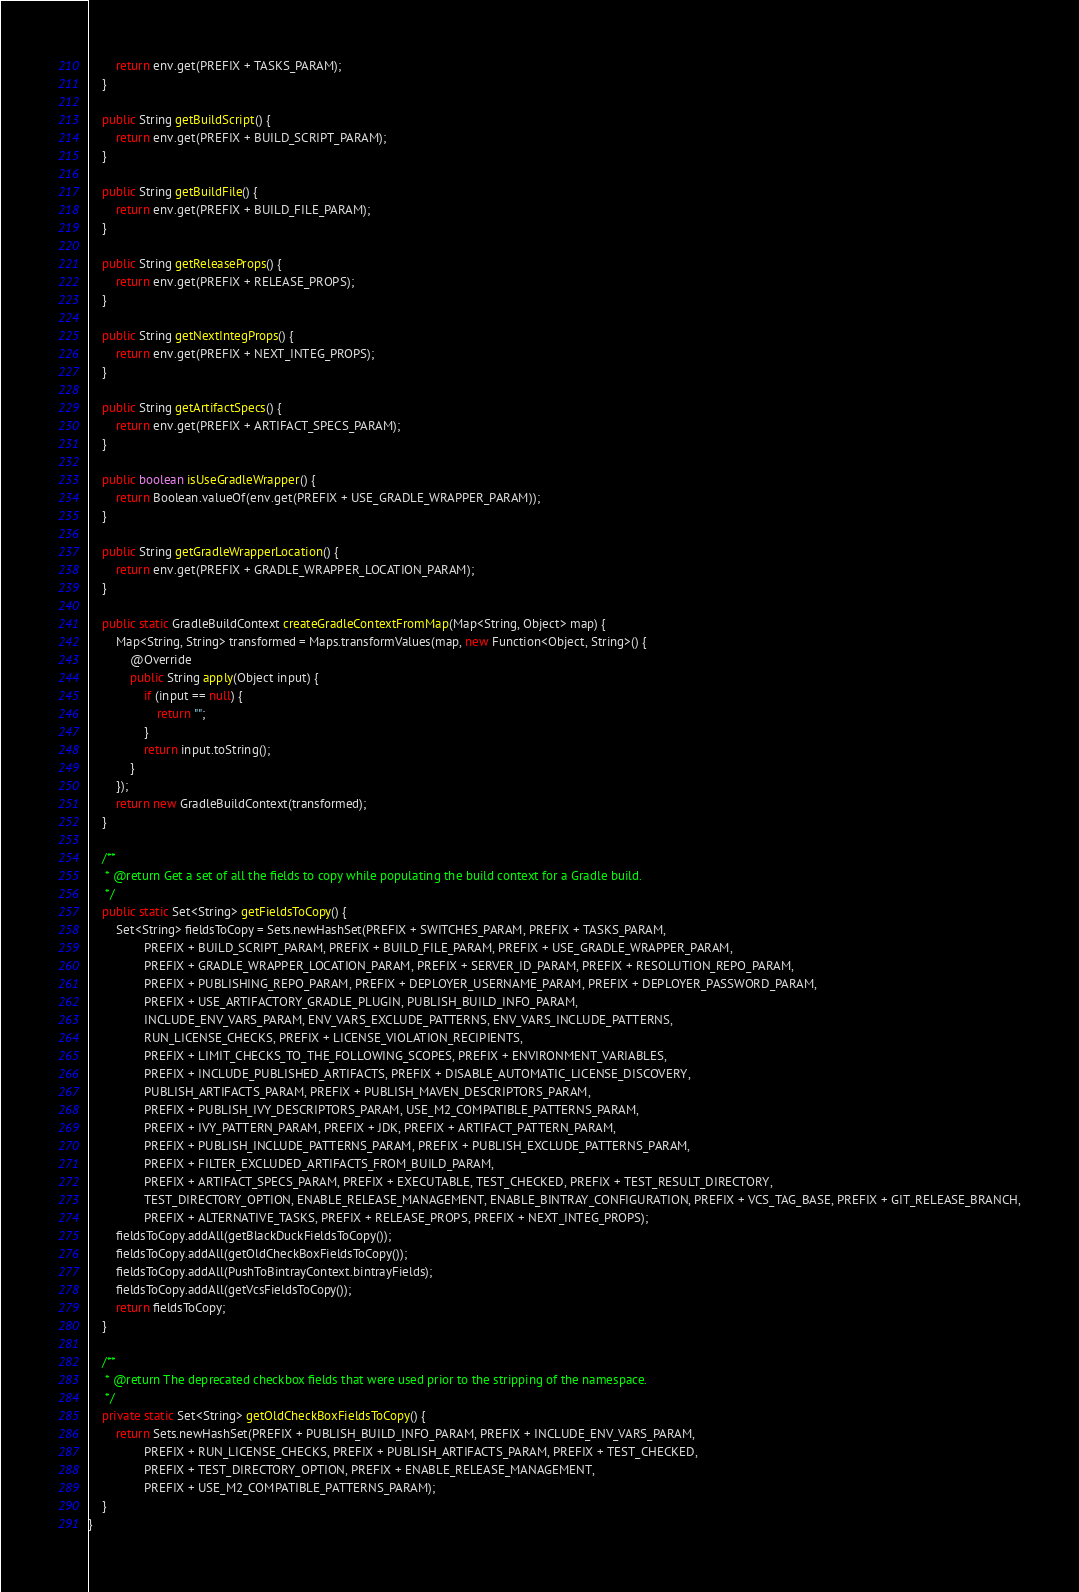Convert code to text. <code><loc_0><loc_0><loc_500><loc_500><_Java_>        return env.get(PREFIX + TASKS_PARAM);
    }

    public String getBuildScript() {
        return env.get(PREFIX + BUILD_SCRIPT_PARAM);
    }

    public String getBuildFile() {
        return env.get(PREFIX + BUILD_FILE_PARAM);
    }

    public String getReleaseProps() {
        return env.get(PREFIX + RELEASE_PROPS);
    }

    public String getNextIntegProps() {
        return env.get(PREFIX + NEXT_INTEG_PROPS);
    }

    public String getArtifactSpecs() {
        return env.get(PREFIX + ARTIFACT_SPECS_PARAM);
    }

    public boolean isUseGradleWrapper() {
        return Boolean.valueOf(env.get(PREFIX + USE_GRADLE_WRAPPER_PARAM));
    }

    public String getGradleWrapperLocation() {
        return env.get(PREFIX + GRADLE_WRAPPER_LOCATION_PARAM);
    }

    public static GradleBuildContext createGradleContextFromMap(Map<String, Object> map) {
        Map<String, String> transformed = Maps.transformValues(map, new Function<Object, String>() {
            @Override
            public String apply(Object input) {
                if (input == null) {
                    return "";
                }
                return input.toString();
            }
        });
        return new GradleBuildContext(transformed);
    }

    /**
     * @return Get a set of all the fields to copy while populating the build context for a Gradle build.
     */
    public static Set<String> getFieldsToCopy() {
        Set<String> fieldsToCopy = Sets.newHashSet(PREFIX + SWITCHES_PARAM, PREFIX + TASKS_PARAM,
                PREFIX + BUILD_SCRIPT_PARAM, PREFIX + BUILD_FILE_PARAM, PREFIX + USE_GRADLE_WRAPPER_PARAM,
                PREFIX + GRADLE_WRAPPER_LOCATION_PARAM, PREFIX + SERVER_ID_PARAM, PREFIX + RESOLUTION_REPO_PARAM,
                PREFIX + PUBLISHING_REPO_PARAM, PREFIX + DEPLOYER_USERNAME_PARAM, PREFIX + DEPLOYER_PASSWORD_PARAM,
                PREFIX + USE_ARTIFACTORY_GRADLE_PLUGIN, PUBLISH_BUILD_INFO_PARAM,
                INCLUDE_ENV_VARS_PARAM, ENV_VARS_EXCLUDE_PATTERNS, ENV_VARS_INCLUDE_PATTERNS,
                RUN_LICENSE_CHECKS, PREFIX + LICENSE_VIOLATION_RECIPIENTS,
                PREFIX + LIMIT_CHECKS_TO_THE_FOLLOWING_SCOPES, PREFIX + ENVIRONMENT_VARIABLES,
                PREFIX + INCLUDE_PUBLISHED_ARTIFACTS, PREFIX + DISABLE_AUTOMATIC_LICENSE_DISCOVERY,
                PUBLISH_ARTIFACTS_PARAM, PREFIX + PUBLISH_MAVEN_DESCRIPTORS_PARAM,
                PREFIX + PUBLISH_IVY_DESCRIPTORS_PARAM, USE_M2_COMPATIBLE_PATTERNS_PARAM,
                PREFIX + IVY_PATTERN_PARAM, PREFIX + JDK, PREFIX + ARTIFACT_PATTERN_PARAM,
                PREFIX + PUBLISH_INCLUDE_PATTERNS_PARAM, PREFIX + PUBLISH_EXCLUDE_PATTERNS_PARAM,
                PREFIX + FILTER_EXCLUDED_ARTIFACTS_FROM_BUILD_PARAM,
                PREFIX + ARTIFACT_SPECS_PARAM, PREFIX + EXECUTABLE, TEST_CHECKED, PREFIX + TEST_RESULT_DIRECTORY,
                TEST_DIRECTORY_OPTION, ENABLE_RELEASE_MANAGEMENT, ENABLE_BINTRAY_CONFIGURATION, PREFIX + VCS_TAG_BASE, PREFIX + GIT_RELEASE_BRANCH,
                PREFIX + ALTERNATIVE_TASKS, PREFIX + RELEASE_PROPS, PREFIX + NEXT_INTEG_PROPS);
        fieldsToCopy.addAll(getBlackDuckFieldsToCopy());
        fieldsToCopy.addAll(getOldCheckBoxFieldsToCopy());
        fieldsToCopy.addAll(PushToBintrayContext.bintrayFields);
        fieldsToCopy.addAll(getVcsFieldsToCopy());
        return fieldsToCopy;
    }

    /**
     * @return The deprecated checkbox fields that were used prior to the stripping of the namespace.
     */
    private static Set<String> getOldCheckBoxFieldsToCopy() {
        return Sets.newHashSet(PREFIX + PUBLISH_BUILD_INFO_PARAM, PREFIX + INCLUDE_ENV_VARS_PARAM,
                PREFIX + RUN_LICENSE_CHECKS, PREFIX + PUBLISH_ARTIFACTS_PARAM, PREFIX + TEST_CHECKED,
                PREFIX + TEST_DIRECTORY_OPTION, PREFIX + ENABLE_RELEASE_MANAGEMENT,
                PREFIX + USE_M2_COMPATIBLE_PATTERNS_PARAM);
    }
}
</code> 